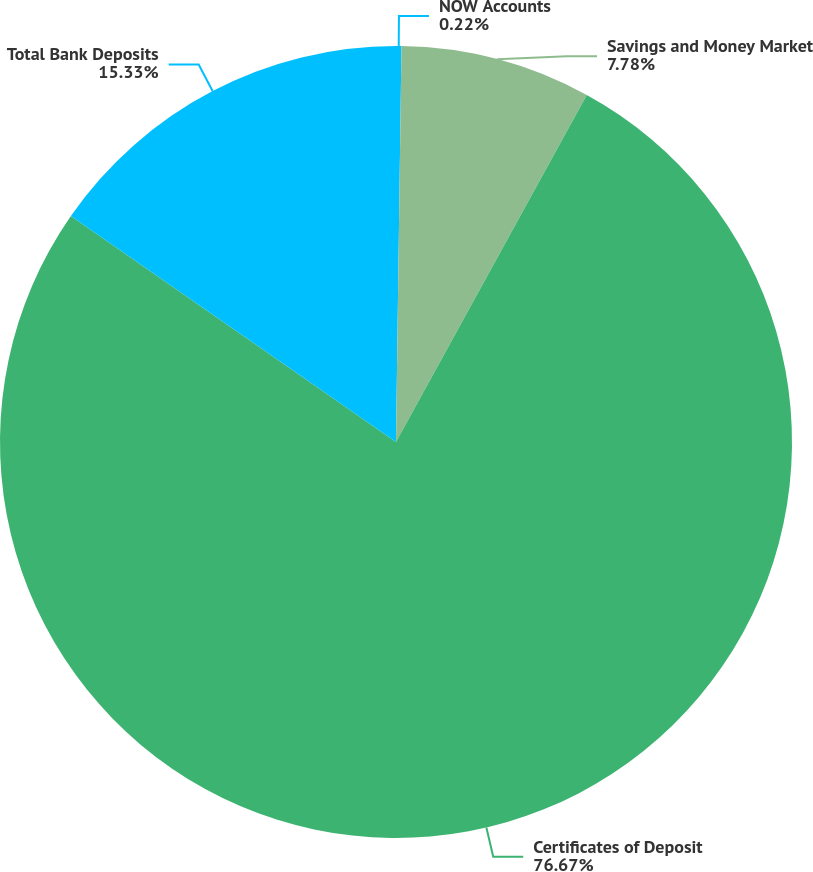<chart> <loc_0><loc_0><loc_500><loc_500><pie_chart><fcel>NOW Accounts<fcel>Savings and Money Market<fcel>Certificates of Deposit<fcel>Total Bank Deposits<nl><fcel>0.22%<fcel>7.78%<fcel>76.67%<fcel>15.33%<nl></chart> 